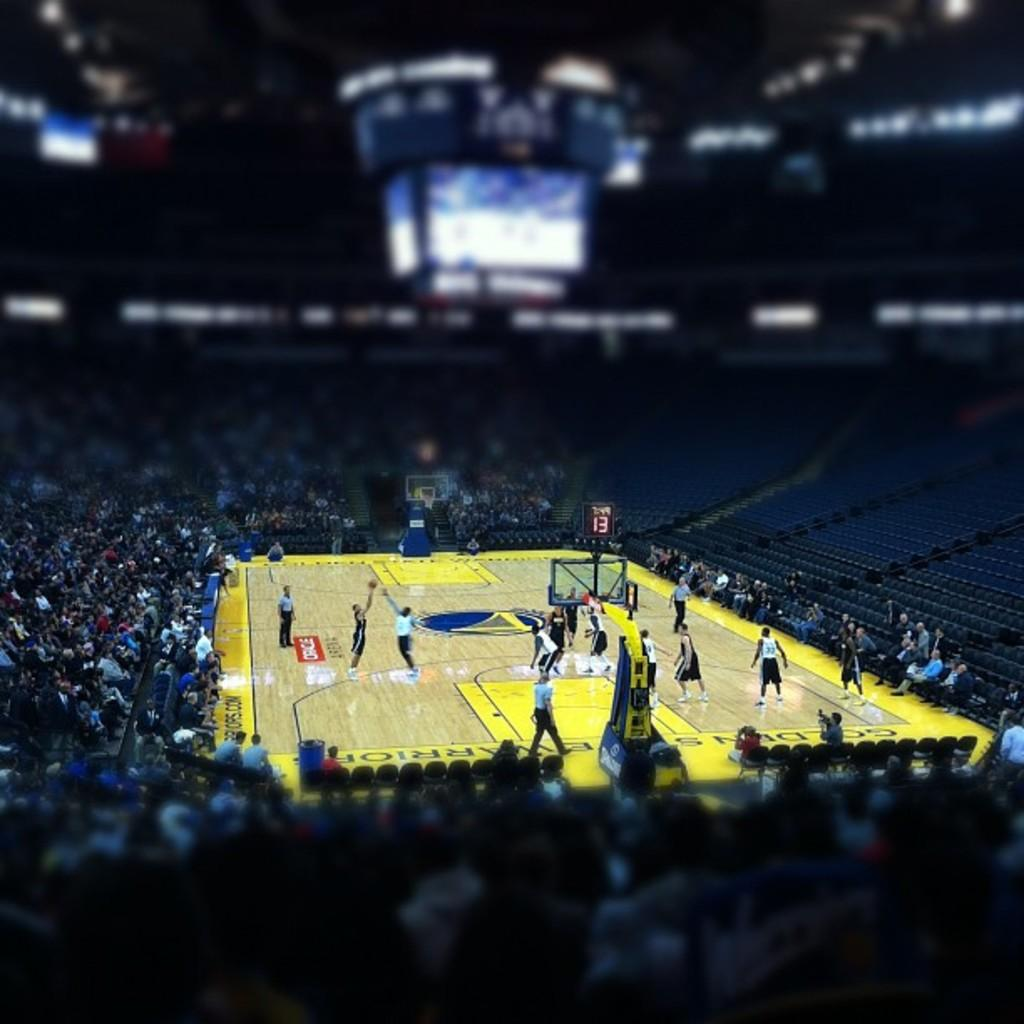What are the people in the image doing? There are people playing in a ground. Where are the other people located in the image? There are people sitting on staircases around the ground. What are the people on the staircases doing? The people on the staircases are watching a match. What type of furniture can be seen in the bedroom in the image? There is no bedroom present in the image; it features people playing in a ground and others watching from staircases. 